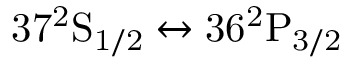Convert formula to latex. <formula><loc_0><loc_0><loc_500><loc_500>3 7 ^ { 2 } S _ { 1 / 2 } \leftrightarrow 3 6 ^ { 2 } P _ { 3 / 2 }</formula> 